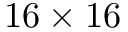Convert formula to latex. <formula><loc_0><loc_0><loc_500><loc_500>1 6 \times 1 6</formula> 